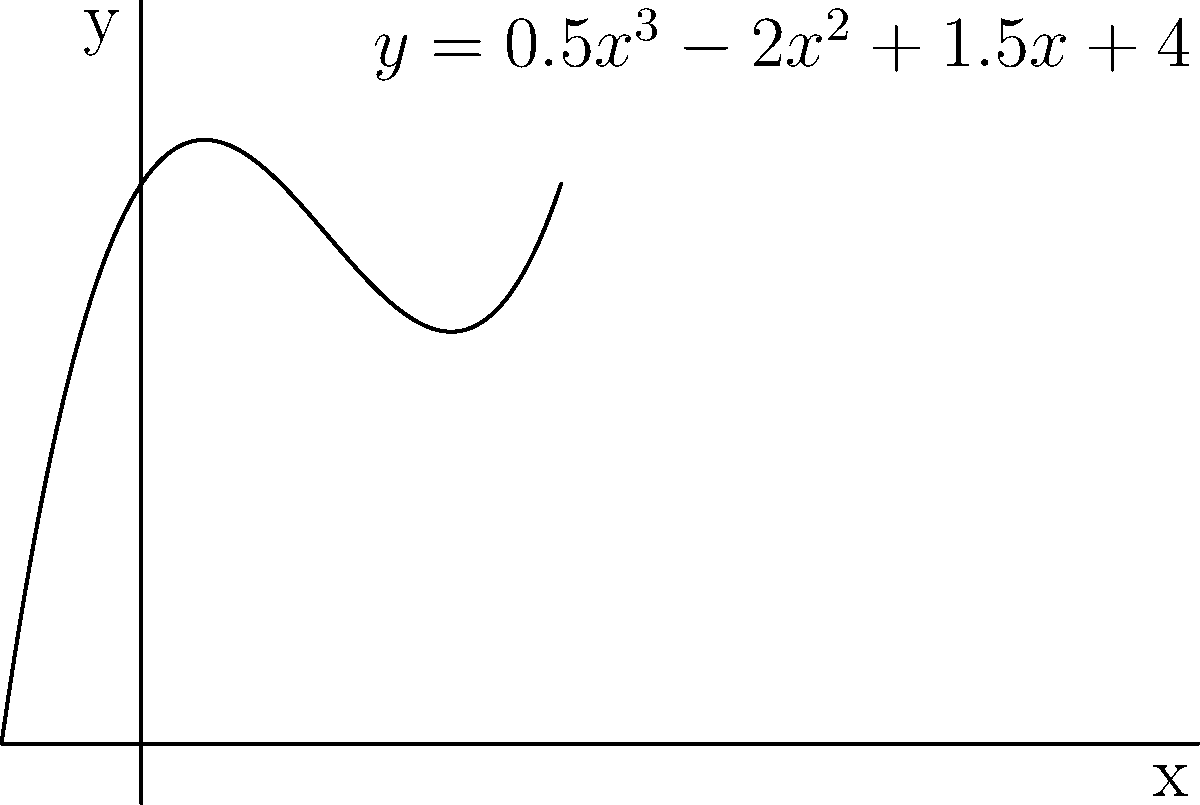En analysant la distribution d'intensité lumineuse dans une photographie, vous avez modélisé la fonction polynomiale suivante : $f(x) = 0.5x^3 - 2x^2 + 1.5x + 4$. Déterminez les coordonnées du point d'inflexion de cette fonction. Pour trouver le point d'inflexion, nous suivons ces étapes :

1) Le point d'inflexion se produit lorsque la dérivée seconde est égale à zéro.

2) Calculons la première dérivée :
   $f'(x) = 1.5x^2 - 4x + 1.5$

3) Calculons la deuxième dérivée :
   $f''(x) = 3x - 4$

4) Trouvons x quand $f''(x) = 0$ :
   $3x - 4 = 0$
   $3x = 4$
   $x = \frac{4}{3}$

5) Pour trouver y, substituons $x = \frac{4}{3}$ dans la fonction originale :
   $f(\frac{4}{3}) = 0.5(\frac{4}{3})^3 - 2(\frac{4}{3})^2 + 1.5(\frac{4}{3}) + 4$
   $= 0.5(\frac{64}{27}) - 2(\frac{16}{9}) + 1.5(\frac{4}{3}) + 4$
   $= \frac{32}{27} - \frac{32}{9} + 2 + 4$
   $= \frac{32}{27} - \frac{96}{27} + \frac{54}{27} + \frac{108}{27}$
   $= \frac{98}{27}$

Donc, le point d'inflexion est $(\frac{4}{3}, \frac{98}{27})$.
Answer: $(\frac{4}{3}, \frac{98}{27})$ 